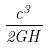Convert formula to latex. <formula><loc_0><loc_0><loc_500><loc_500>\frac { c ^ { 3 } } { 2 G H }</formula> 